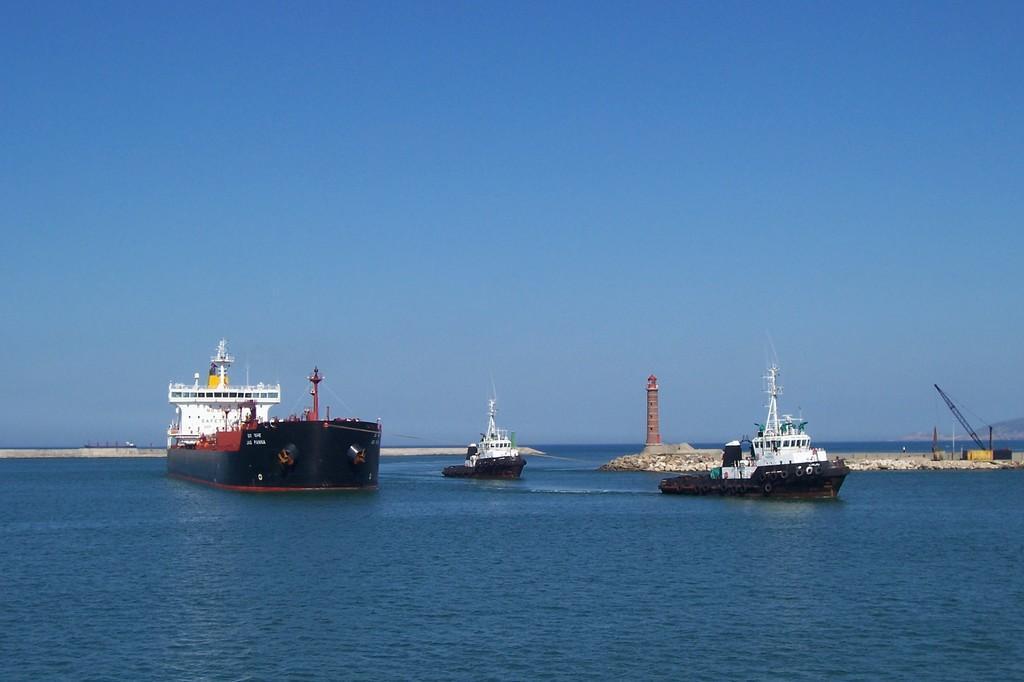Describe this image in one or two sentences. In the foreground of this image, there are ships on the water. In the background, there is a lighthouse, few objects and the sky. 